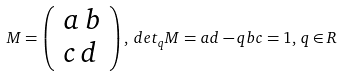<formula> <loc_0><loc_0><loc_500><loc_500>M = \left ( \begin{array} { l l } a \, b \\ c \, d \\ \end{array} \right ) , \, d e t _ { q } M = a d - q b c = 1 , \, q \in R</formula> 